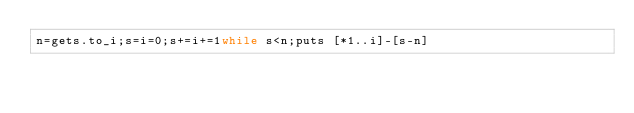Convert code to text. <code><loc_0><loc_0><loc_500><loc_500><_Ruby_>n=gets.to_i;s=i=0;s+=i+=1while s<n;puts [*1..i]-[s-n]</code> 